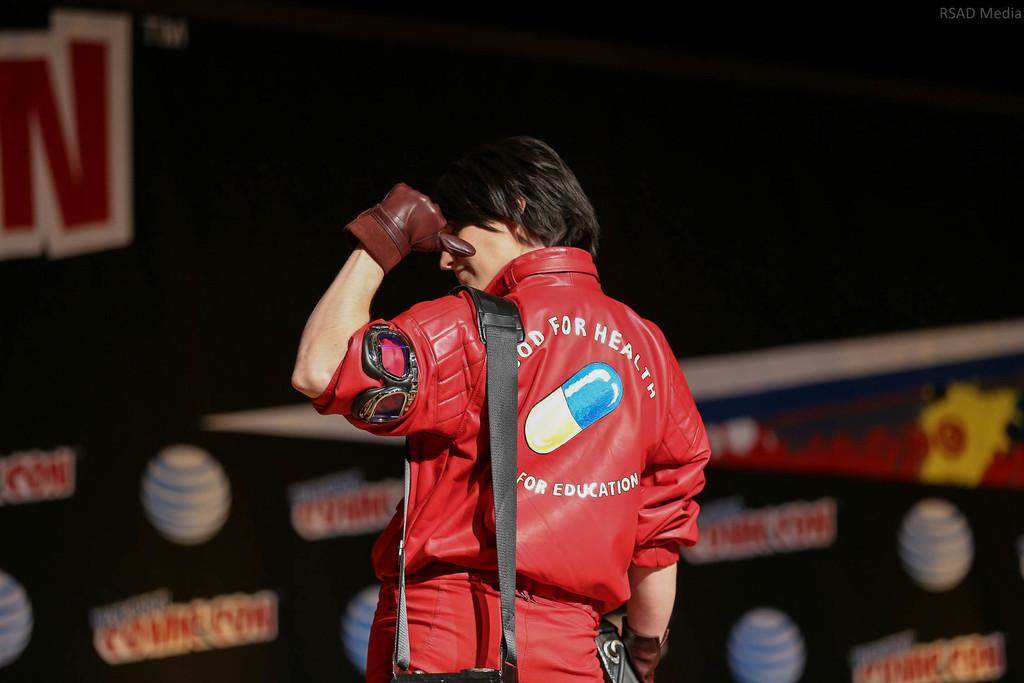<image>
Describe the image concisely. A person points to the picture of a pill on the back of their shirt with the words for education below it. 